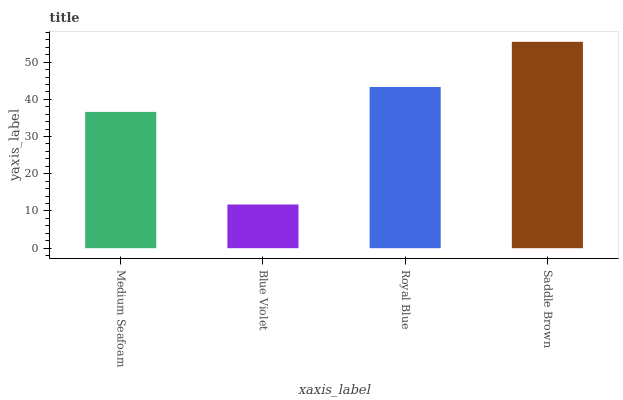Is Blue Violet the minimum?
Answer yes or no. Yes. Is Saddle Brown the maximum?
Answer yes or no. Yes. Is Royal Blue the minimum?
Answer yes or no. No. Is Royal Blue the maximum?
Answer yes or no. No. Is Royal Blue greater than Blue Violet?
Answer yes or no. Yes. Is Blue Violet less than Royal Blue?
Answer yes or no. Yes. Is Blue Violet greater than Royal Blue?
Answer yes or no. No. Is Royal Blue less than Blue Violet?
Answer yes or no. No. Is Royal Blue the high median?
Answer yes or no. Yes. Is Medium Seafoam the low median?
Answer yes or no. Yes. Is Medium Seafoam the high median?
Answer yes or no. No. Is Blue Violet the low median?
Answer yes or no. No. 